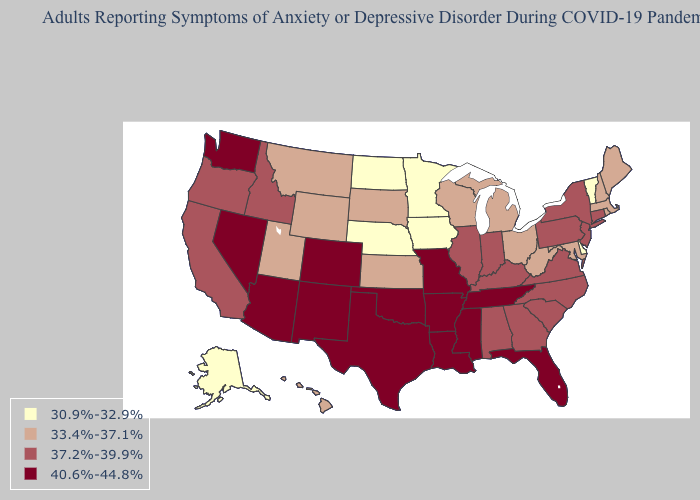Does Hawaii have the same value as Wisconsin?
Answer briefly. Yes. Does Iowa have the lowest value in the USA?
Concise answer only. Yes. Name the states that have a value in the range 30.9%-32.9%?
Keep it brief. Alaska, Delaware, Iowa, Minnesota, Nebraska, North Dakota, Vermont. Name the states that have a value in the range 37.2%-39.9%?
Write a very short answer. Alabama, California, Connecticut, Georgia, Idaho, Illinois, Indiana, Kentucky, New Jersey, New York, North Carolina, Oregon, Pennsylvania, South Carolina, Virginia. What is the lowest value in states that border Rhode Island?
Be succinct. 33.4%-37.1%. Which states hav the highest value in the South?
Answer briefly. Arkansas, Florida, Louisiana, Mississippi, Oklahoma, Tennessee, Texas. Among the states that border Missouri , does Iowa have the lowest value?
Write a very short answer. Yes. Does the map have missing data?
Write a very short answer. No. What is the value of Washington?
Give a very brief answer. 40.6%-44.8%. Does Alaska have the lowest value in the USA?
Give a very brief answer. Yes. What is the lowest value in the Northeast?
Answer briefly. 30.9%-32.9%. What is the value of Nebraska?
Quick response, please. 30.9%-32.9%. What is the highest value in states that border Idaho?
Give a very brief answer. 40.6%-44.8%. What is the value of Alaska?
Write a very short answer. 30.9%-32.9%. Among the states that border Kansas , does Nebraska have the highest value?
Write a very short answer. No. 